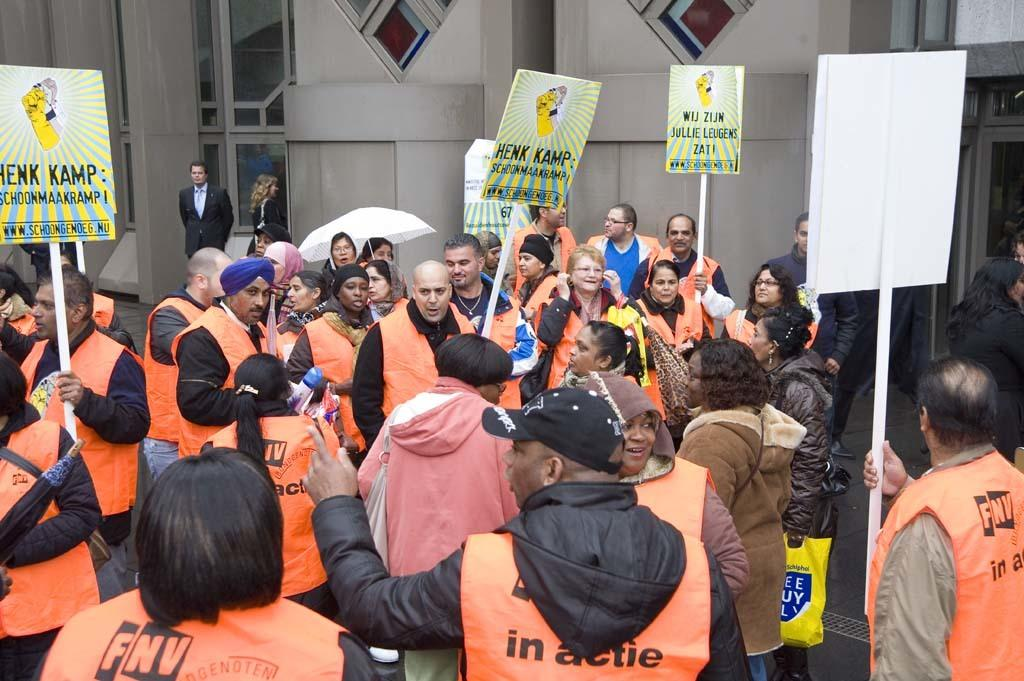Provide a one-sentence caption for the provided image. Protester in the street gather about Henk Kamp. 